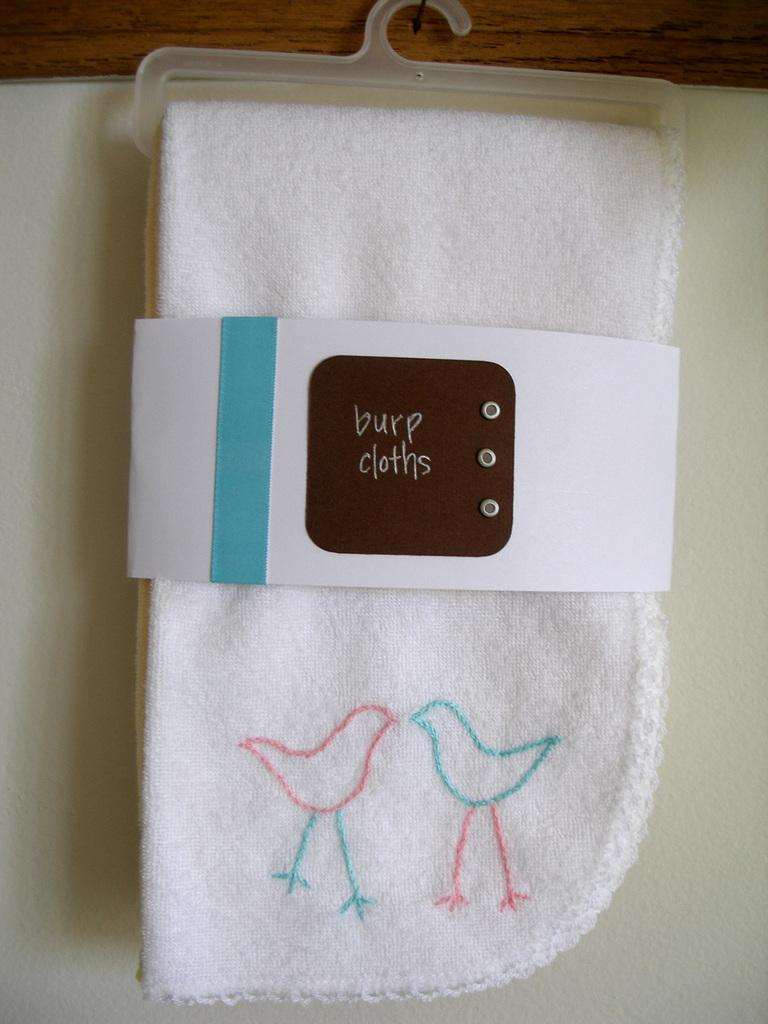What is on the napkin in the image? There is a paper on the napkin in the image. How is the napkin positioned in the image? The napkin is on a hanger. What is the hanger attached to in the image? The hanger is hanging on a wooden board. Can you hear the voice of the person who wrote the paper on the napkin? There is no indication of a person or their voice in the image, as it only shows a napkin with a paper on it, a hanger, and a wooden board. 